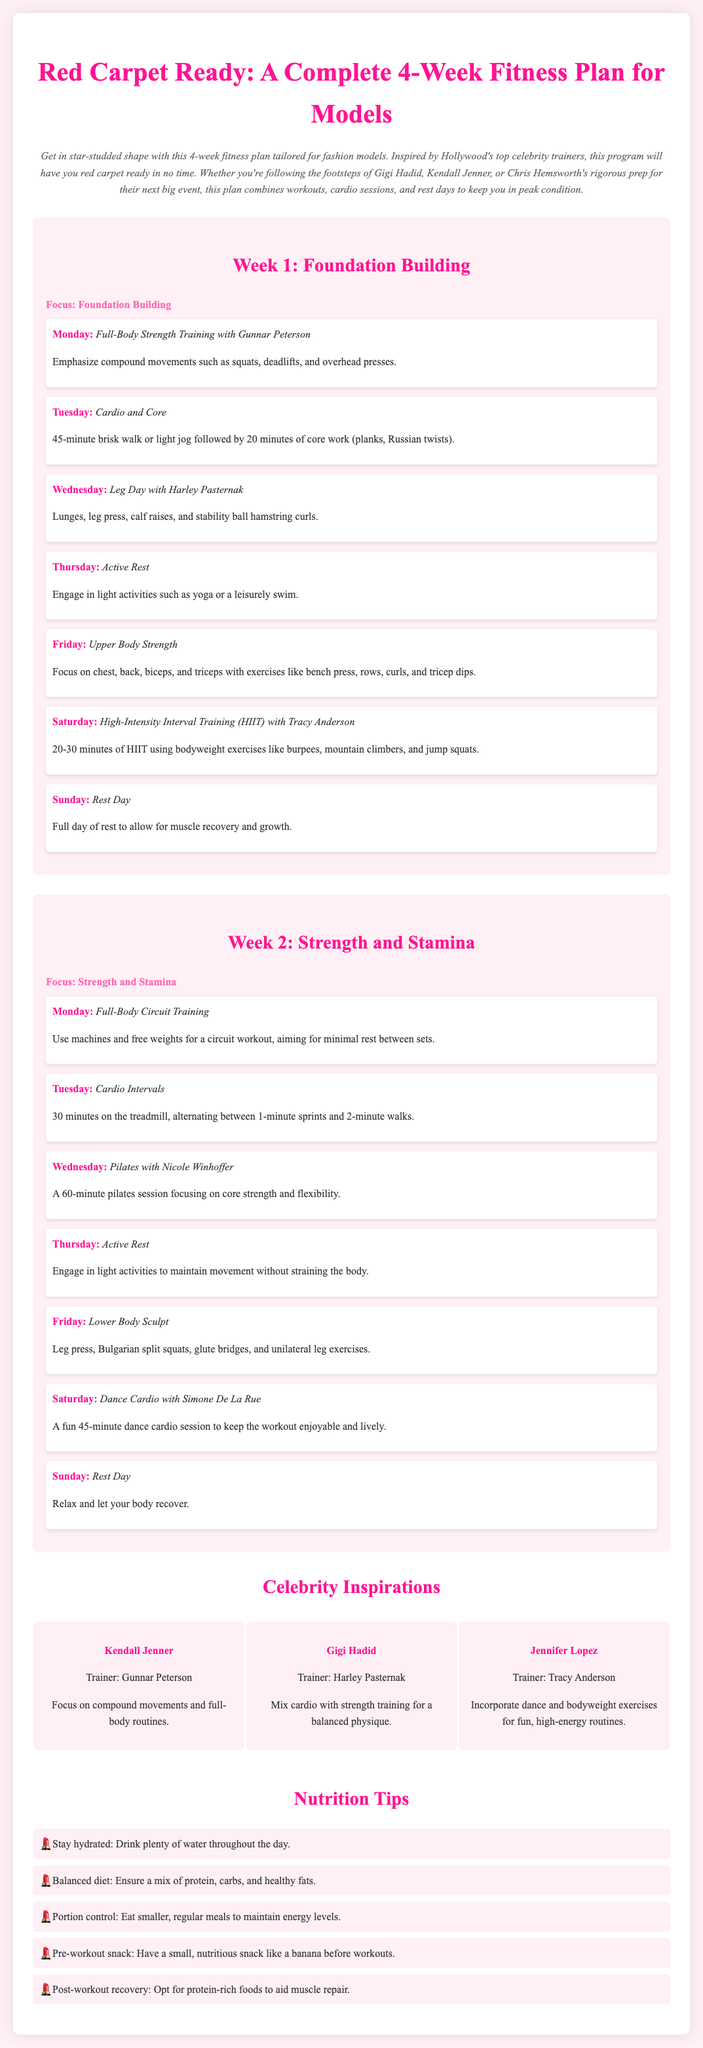What is the title of the fitness plan? The title of the document is presented at the top and describes the overarching theme of the content.
Answer: Red Carpet Ready: A Complete 4-Week Fitness Plan for Models What is the focus of Week 1? The document states the specific focus of each week in the corresponding section.
Answer: Foundation Building Which celebrity is associated with Gunnar Peterson? The celebrity inspirations section lists trainers alongside their associated celebrities.
Answer: Kendall Jenner How long is the cardio session on Tuesday of Week 1? The document provides specific durations for activities listed in the workout plan.
Answer: 45 minutes What type of workout does Saturday in Week 2 consist of? The workout activities for each day detail the specific type for the Saturday of Week 2.
Answer: Dance Cardio with Simone De La Rue How many rest days are included in the 4-week plan? The number of rest days can be calculated from the weekly schedules presented.
Answer: 8 days What exercise is part of the Upper Body Strength workout? There are specific exercises listed under different workouts that provide clarity on what to expect.
Answer: Bench press What is one nutrition tip provided in the document? The nutrition tips section features a list of suggestions for a balanced diet.
Answer: Stay hydrated: Drink plenty of water throughout the day 